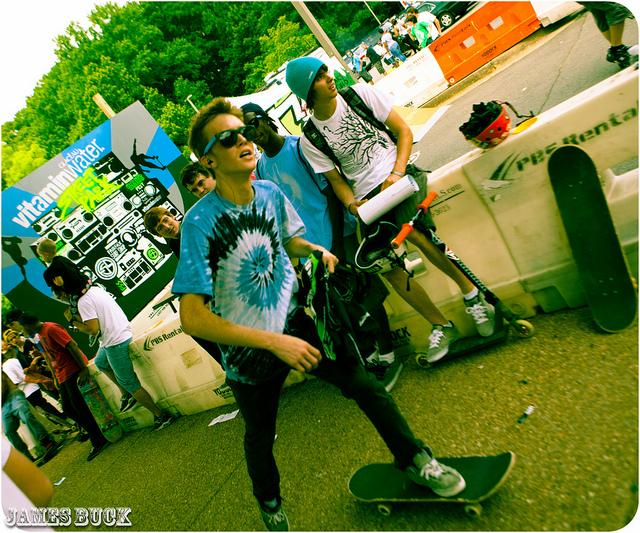What type of event is happening here? scatting 